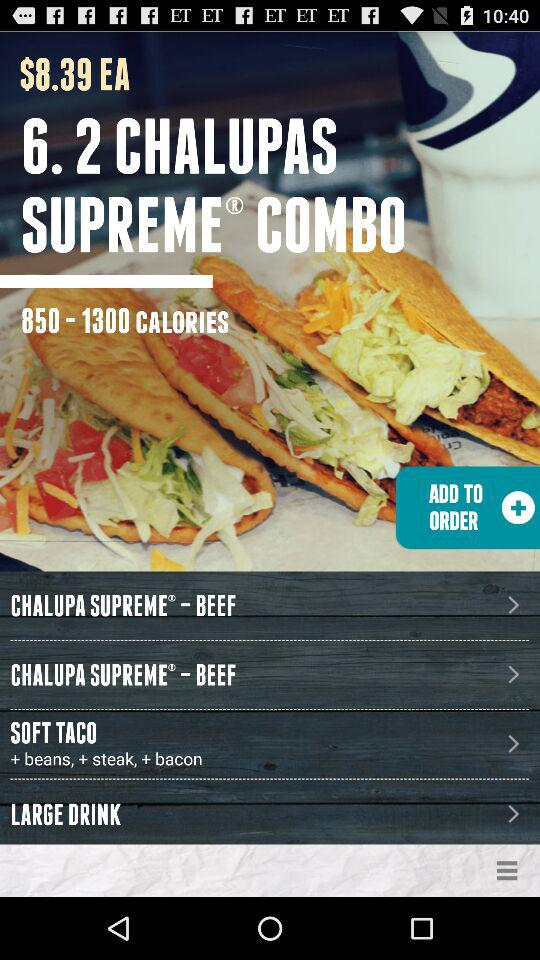How many calories are in the chalupa supreme?
Answer the question using a single word or phrase. 850-1300 